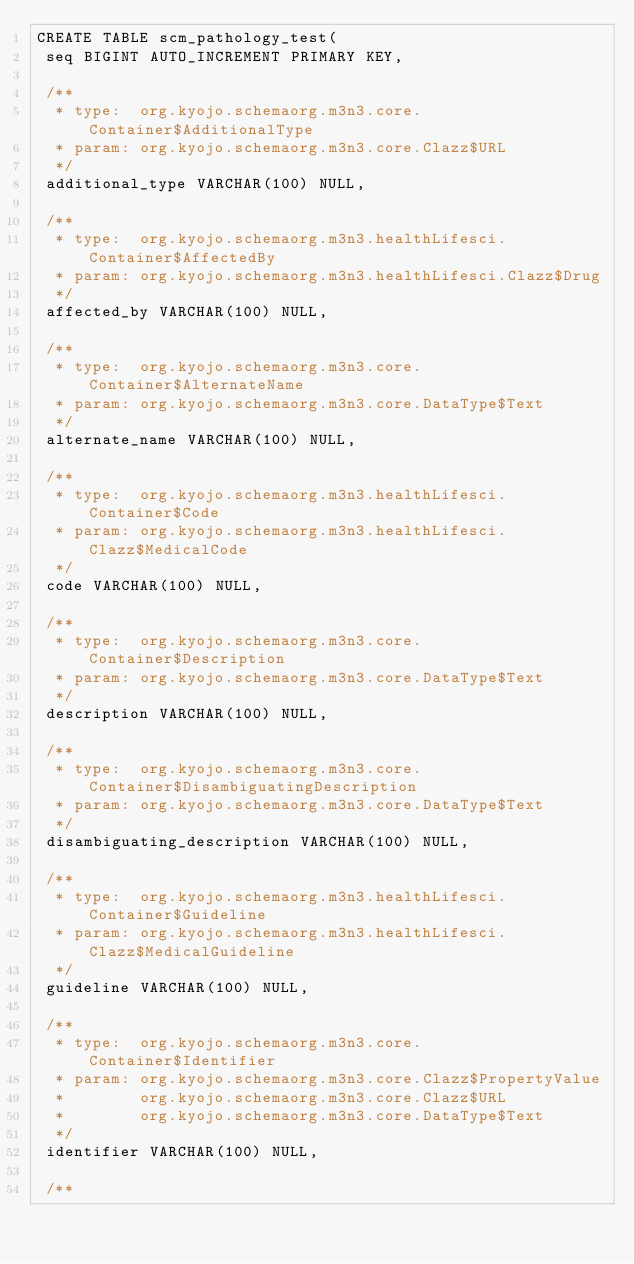<code> <loc_0><loc_0><loc_500><loc_500><_SQL_>CREATE TABLE scm_pathology_test(
 seq BIGINT AUTO_INCREMENT PRIMARY KEY,

 /**
  * type:  org.kyojo.schemaorg.m3n3.core.Container$AdditionalType
  * param: org.kyojo.schemaorg.m3n3.core.Clazz$URL
  */
 additional_type VARCHAR(100) NULL,

 /**
  * type:  org.kyojo.schemaorg.m3n3.healthLifesci.Container$AffectedBy
  * param: org.kyojo.schemaorg.m3n3.healthLifesci.Clazz$Drug
  */
 affected_by VARCHAR(100) NULL,

 /**
  * type:  org.kyojo.schemaorg.m3n3.core.Container$AlternateName
  * param: org.kyojo.schemaorg.m3n3.core.DataType$Text
  */
 alternate_name VARCHAR(100) NULL,

 /**
  * type:  org.kyojo.schemaorg.m3n3.healthLifesci.Container$Code
  * param: org.kyojo.schemaorg.m3n3.healthLifesci.Clazz$MedicalCode
  */
 code VARCHAR(100) NULL,

 /**
  * type:  org.kyojo.schemaorg.m3n3.core.Container$Description
  * param: org.kyojo.schemaorg.m3n3.core.DataType$Text
  */
 description VARCHAR(100) NULL,

 /**
  * type:  org.kyojo.schemaorg.m3n3.core.Container$DisambiguatingDescription
  * param: org.kyojo.schemaorg.m3n3.core.DataType$Text
  */
 disambiguating_description VARCHAR(100) NULL,

 /**
  * type:  org.kyojo.schemaorg.m3n3.healthLifesci.Container$Guideline
  * param: org.kyojo.schemaorg.m3n3.healthLifesci.Clazz$MedicalGuideline
  */
 guideline VARCHAR(100) NULL,

 /**
  * type:  org.kyojo.schemaorg.m3n3.core.Container$Identifier
  * param: org.kyojo.schemaorg.m3n3.core.Clazz$PropertyValue
  *        org.kyojo.schemaorg.m3n3.core.Clazz$URL
  *        org.kyojo.schemaorg.m3n3.core.DataType$Text
  */
 identifier VARCHAR(100) NULL,

 /**</code> 